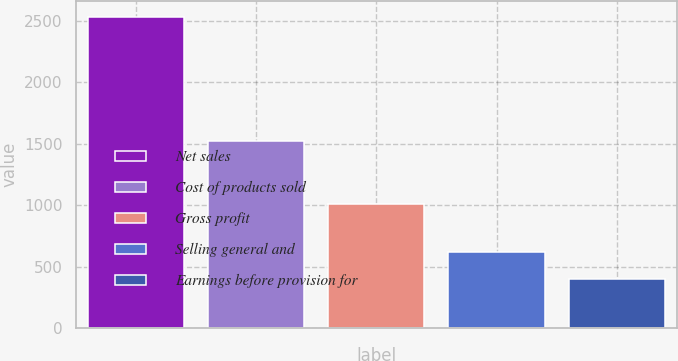Convert chart. <chart><loc_0><loc_0><loc_500><loc_500><bar_chart><fcel>Net sales<fcel>Cost of products sold<fcel>Gross profit<fcel>Selling general and<fcel>Earnings before provision for<nl><fcel>2536.5<fcel>1526.7<fcel>1009.8<fcel>615.9<fcel>402.5<nl></chart> 